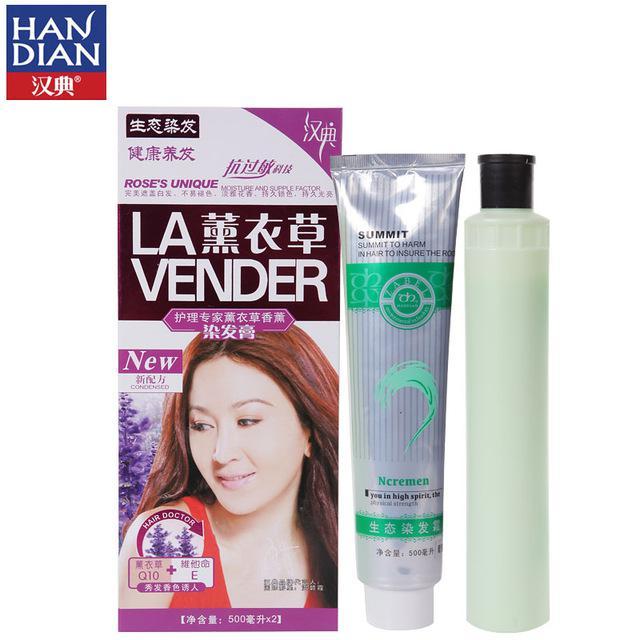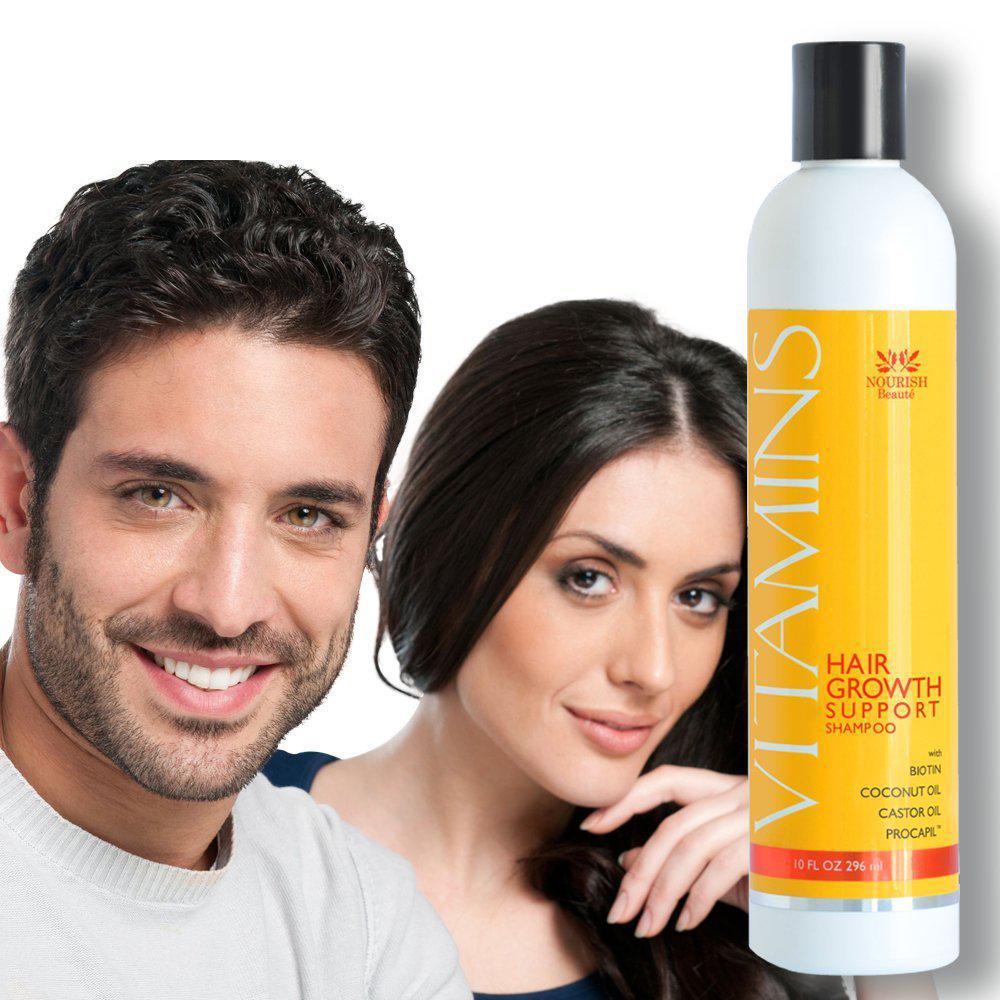The first image is the image on the left, the second image is the image on the right. For the images shown, is this caption "All of the bottles in the images are green." true? Answer yes or no. No. The first image is the image on the left, the second image is the image on the right. Assess this claim about the two images: "A female has her hand touching her face, and an upright bottle overlaps the image.". Correct or not? Answer yes or no. Yes. 